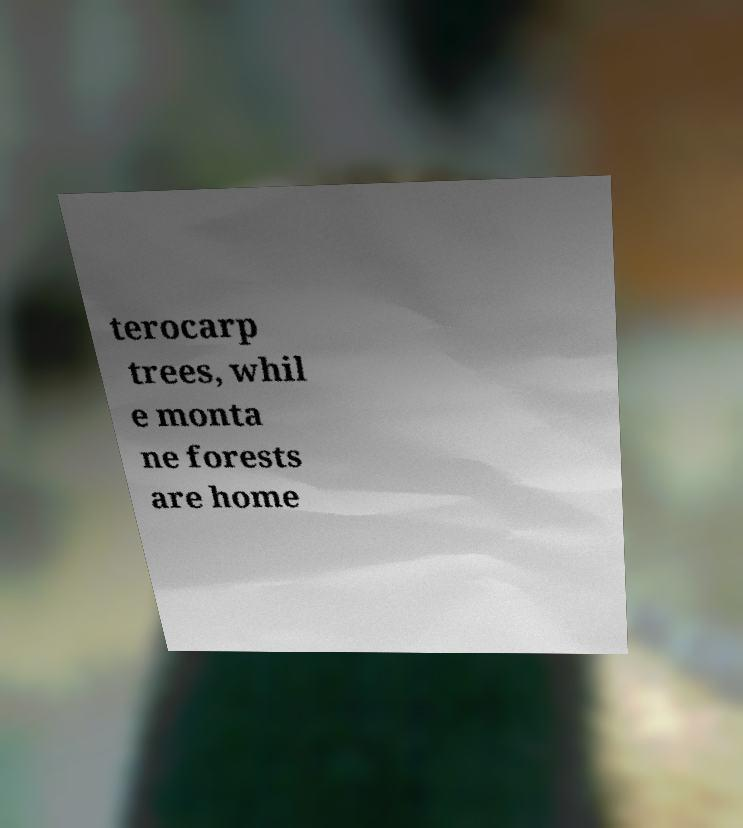There's text embedded in this image that I need extracted. Can you transcribe it verbatim? terocarp trees, whil e monta ne forests are home 